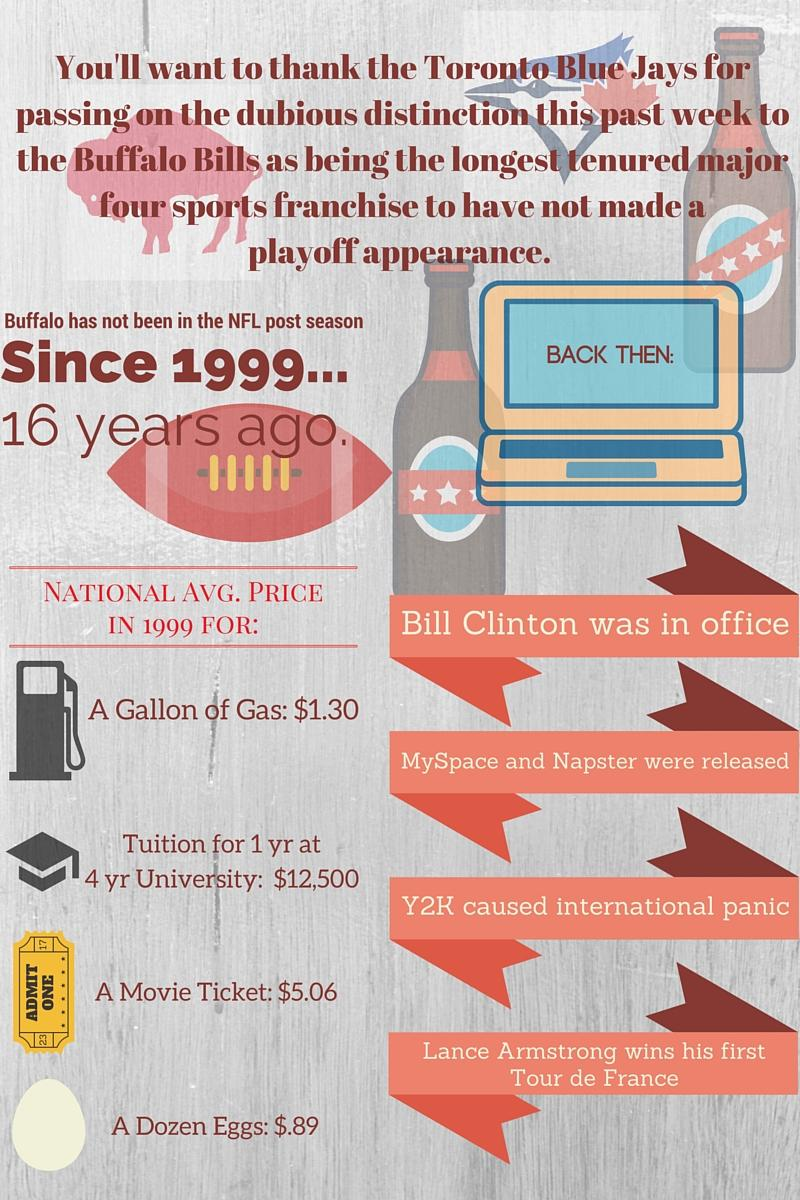Mention a couple of crucial points in this snapshot. The content displayed on the computer screen during that time period was... Y2K caused international panic in the year 1999. MySpace and Napster were released in 1999. In the year 1999, the President of the United States was Bill Clinton. When Lance Armstrong won his first Tour de France in 1999, it marked a significant moment in his career and the history of the sport. 